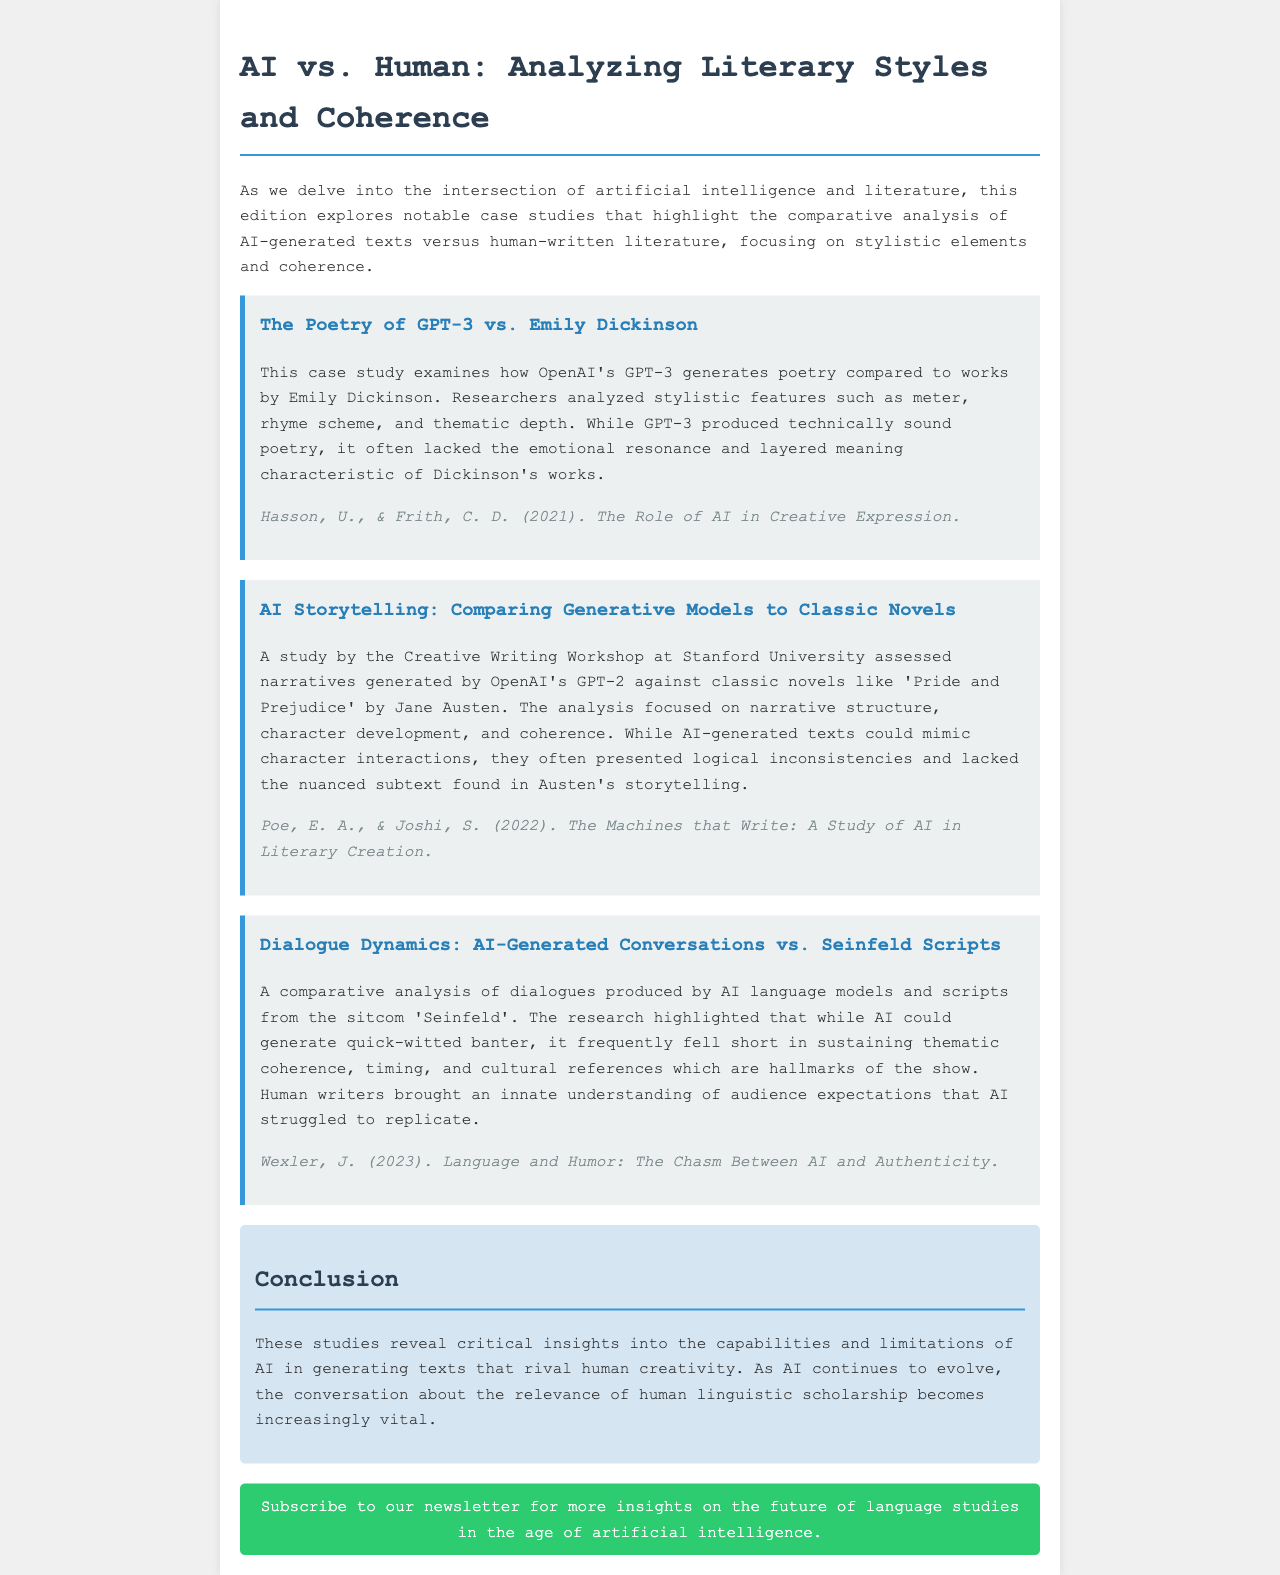What is the title of the newsletter? The title of the newsletter is provided in the <title> tag of the document, which reads "AI vs. Human: Analyzing Literary Styles and Coherence."
Answer: AI vs. Human: Analyzing Literary Styles and Coherence Who is the author of the case study on AI storytelling? The author of the case study "AI Storytelling: Comparing Generative Models to Classic Novels" is cited in the reference section of the case study as Poe, E. A., & Joshi, S.
Answer: Poe, E. A., & Joshi, S What year was the research on dialogue dynamics published? The research on dialogue dynamics is referenced with the date 2023 in the document, which indicates when it was published.
Answer: 2023 Which author is mentioned in the poetry case study? The poetry case study compares AI-generated work to that of Emily Dickinson, who is directly named in the case study as a reference point for style comparison.
Answer: Emily Dickinson What literary element did researchers analyze in the GPT-3 poetry study? The discussion of the study highlights the analysis of stylistic features such as meter and rhyme scheme, which are essential elements of poetry.
Answer: Meter, rhyme scheme How did AI-generated dialogues compare to Seinfeld scripts? The document states that AI-generated dialogues fell short in sustaining thematic coherence, timing, and cultural references inherent in Seinfeld scripts.
Answer: Thematic coherence, timing, cultural references What is the main conclusion drawn from the studies in the newsletter? The conclusion drawn from the studies emphasizes the insights into the capabilities and limitations of AI in generating texts that rival human creativity, which reflects a deeper understanding of their relationship.
Answer: Capabilities and limitations of AI 